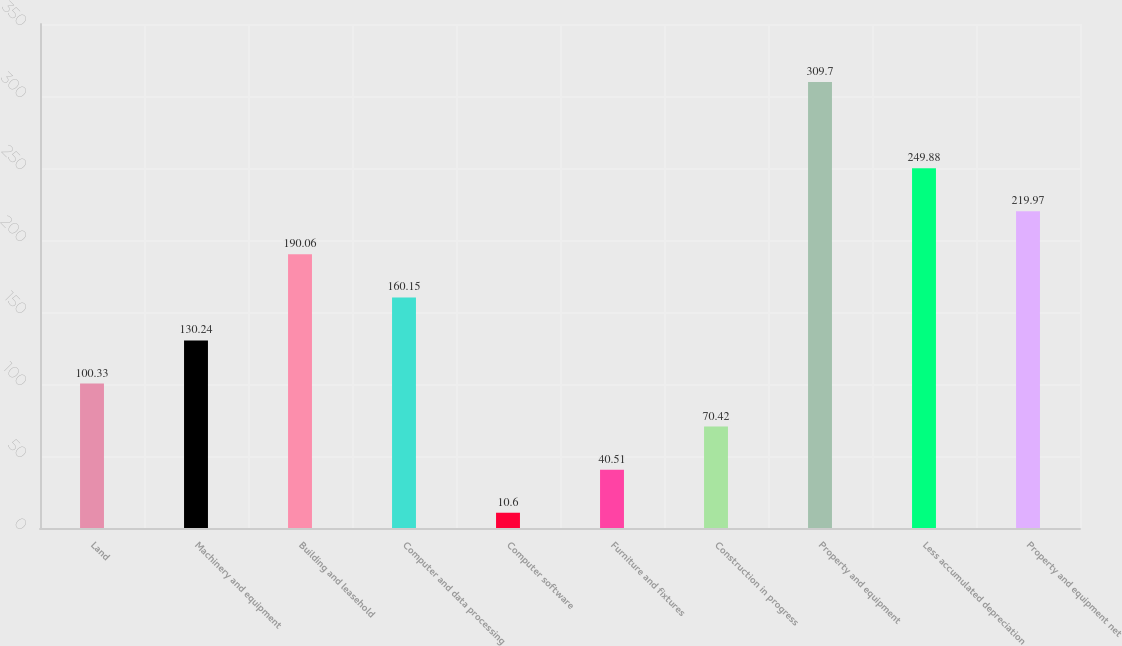<chart> <loc_0><loc_0><loc_500><loc_500><bar_chart><fcel>Land<fcel>Machinery and equipment<fcel>Building and leasehold<fcel>Computer and data processing<fcel>Computer software<fcel>Furniture and fixtures<fcel>Construction in progress<fcel>Property and equipment<fcel>Less accumulated depreciation<fcel>Property and equipment net<nl><fcel>100.33<fcel>130.24<fcel>190.06<fcel>160.15<fcel>10.6<fcel>40.51<fcel>70.42<fcel>309.7<fcel>249.88<fcel>219.97<nl></chart> 